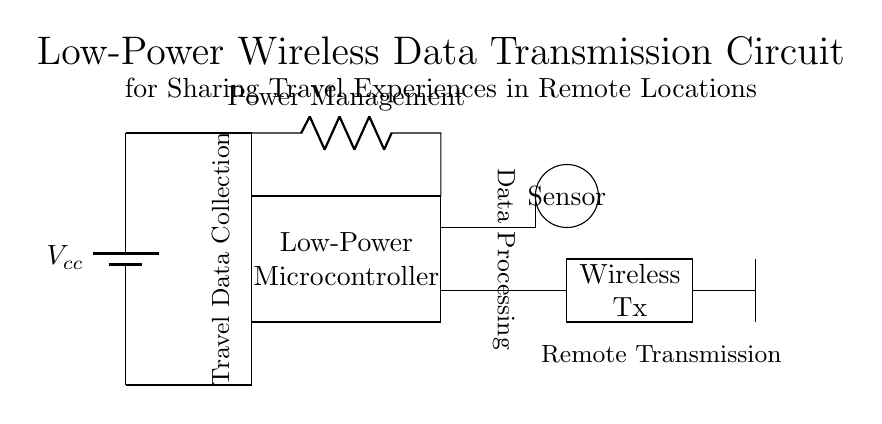What is the main power source in the circuit? The main power source is a battery, indicated as Vcc, which supplies energy to the circuit components.
Answer: Battery What type of microcontroller is used? The circuit features a low-power microcontroller, which is essential for energy efficiency in remote locations.
Answer: Low-Power Microcontroller What is the purpose of the wireless transmitter? The wireless transmitter (labeled as Wireless Tx) is responsible for sending the collected data wirelessly to a remote location.
Answer: Remote Transmission How many main components are there in the circuit? The circuit contains four main components: a battery, microcontroller, sensor, and wireless transmitter.
Answer: Four Why is power management important in this circuit? Power management is crucial because it regulates the energy consumption of the components, ensuring they operate efficiently, especially for battery-operated devices in remote areas.
Answer: To regulate energy consumption What is the function of the antenna in this circuit? The antenna facilitates the transmission of data wirelessly, allowing for communication with other devices or networks.
Answer: Transmission of data 